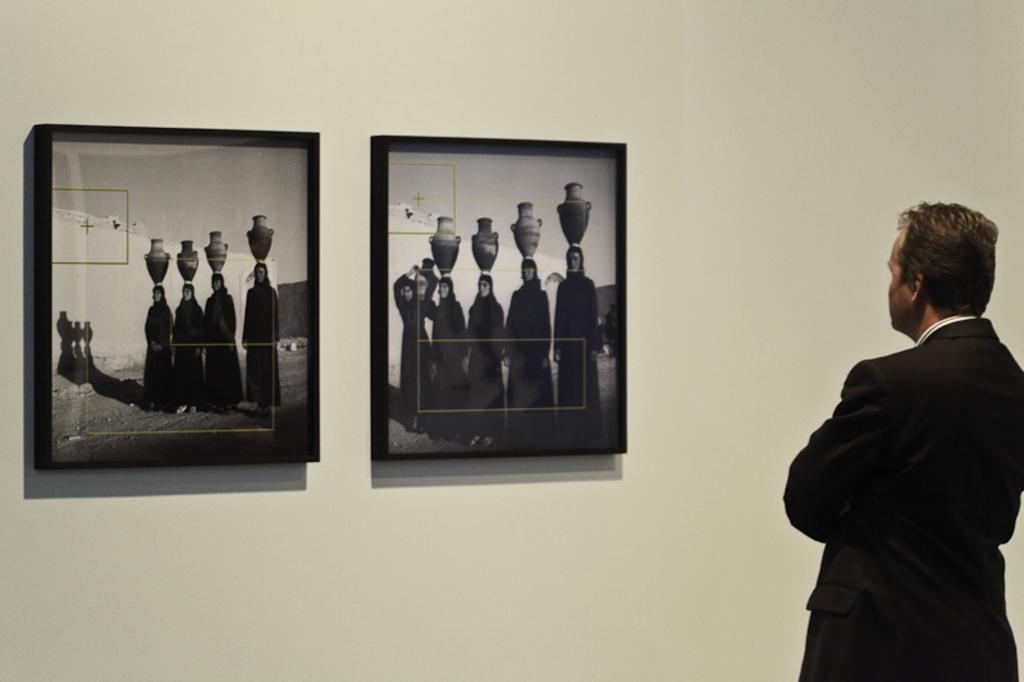Can you describe this image briefly? In the image we can see a person standing and the persons facing back. We can even see two frames stick to the wall. 